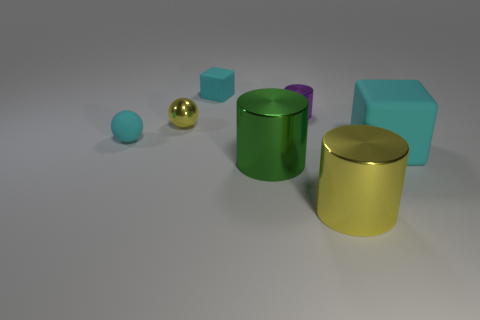What size is the rubber sphere that is the same color as the large cube?
Provide a succinct answer. Small. What shape is the big object that is the same color as the tiny shiny ball?
Make the answer very short. Cylinder. Is there any other thing that has the same color as the shiny sphere?
Offer a terse response. Yes. Do the purple cylinder and the matte ball have the same size?
Give a very brief answer. Yes. How many things are cubes right of the purple metal object or cyan things that are behind the purple cylinder?
Your response must be concise. 2. The yellow object that is behind the cyan object that is to the right of the tiny cyan cube is made of what material?
Keep it short and to the point. Metal. What number of other things are made of the same material as the large green object?
Your response must be concise. 3. Do the large yellow metallic thing and the small yellow thing have the same shape?
Ensure brevity in your answer.  No. There is a yellow shiny ball to the left of the big yellow metal cylinder; how big is it?
Offer a terse response. Small. There is a green metal object; is it the same size as the object behind the small cylinder?
Ensure brevity in your answer.  No. 